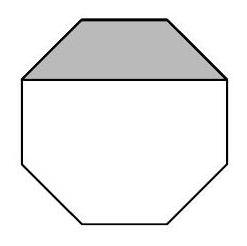The diagram shows a regular octagon, with a line drawn between two of its vertices. The shaded area measures $3 \mathrm{~cm}^{2}$. What is the area of the octagon in square centimetres? To find the full area of the octagon from the given shaded section, additional geometric relationships or calculations are required. We need to know the number of such sections or the relationship between the shaded section and the total area. Without this information, a precise answer cannot be given. Further clarification about the properties of the sections or additional measurements from other parts of the octagon would be necessary to provide a complete answer. 